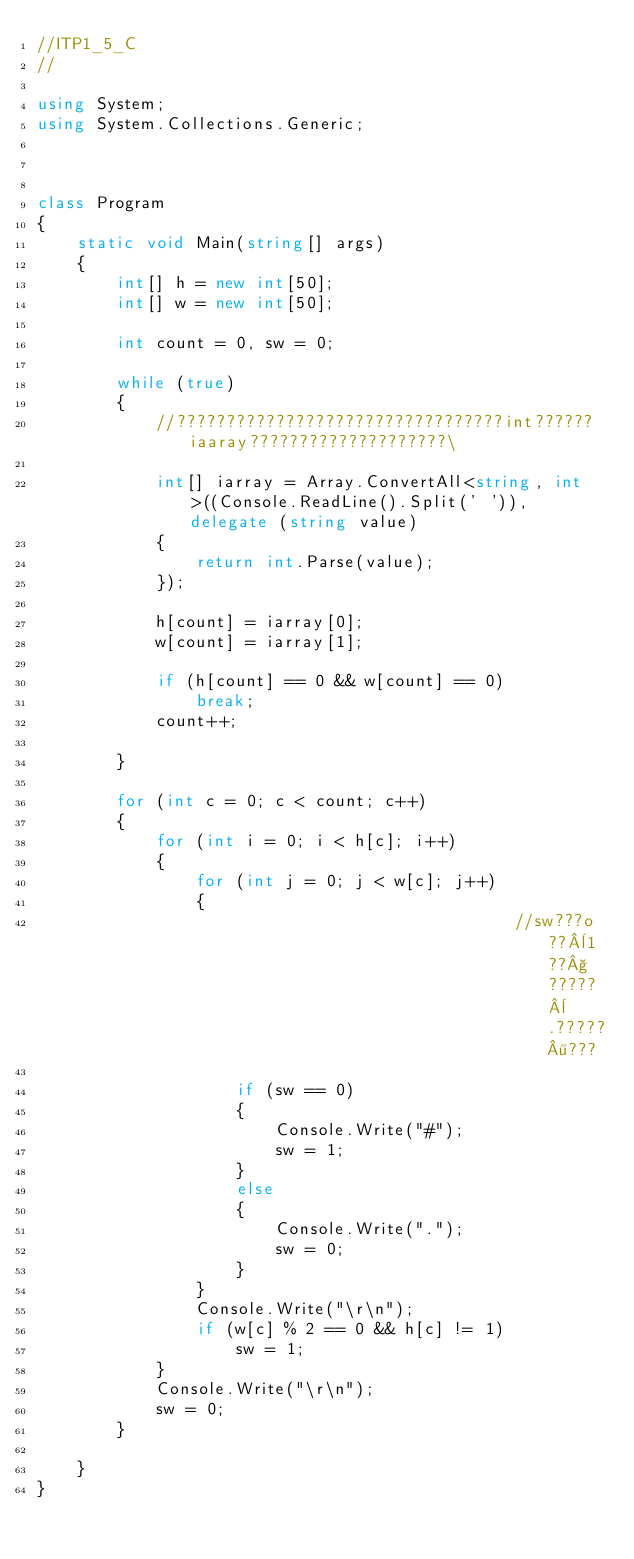<code> <loc_0><loc_0><loc_500><loc_500><_C#_>//ITP1_5_C
//

using System;
using System.Collections.Generic;



class Program
{
    static void Main(string[] args)
    {
        int[] h = new int[50];
        int[] w = new int[50];

        int count = 0, sw = 0;

        while (true)
        {
            //?????????????????????????????????int??????iaaray????????????????????\

            int[] iarray = Array.ConvertAll<string, int>((Console.ReadLine().Split(' ')), delegate (string value)
            {
                return int.Parse(value);
            });

            h[count] = iarray[0];
            w[count] = iarray[1];

            if (h[count] == 0 && w[count] == 0)
                break;
            count++;

        }

        for (int c = 0; c < count; c++)
        {
            for (int i = 0; i < h[c]; i++)
            {
                for (int j = 0; j < w[c]; j++)
                {                   
                                                //sw???o??¨1??§?????¨.?????¶???

                    if (sw == 0)
                    {
                        Console.Write("#");
                        sw = 1;
                    }
                    else
                    {
                        Console.Write(".");
                        sw = 0;
                    }
                }
                Console.Write("\r\n");
                if (w[c] % 2 == 0 && h[c] != 1)
                    sw = 1;
            }
            Console.Write("\r\n");
            sw = 0;
        }

    }
}</code> 